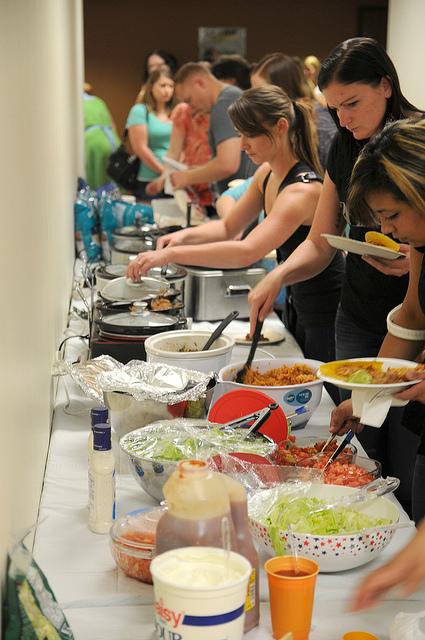What are the utensils that are black?
Write a very short answer. Spoons. What kind of cup is the red cup?
Give a very brief answer. Plastic cup. How many kids are in the scene?
Keep it brief. 0. Are they drinking soda?
Quick response, please. No. Is this a buffet style dinner?
Keep it brief. Yes. Is there a man in this picture?
Be succinct. Yes. What are they eating?
Concise answer only. Salad. What condiment is on the table?
Concise answer only. Sour cream. Is there sour cream in the photo?
Write a very short answer. Yes. What condiment is shown?
Short answer required. Salad dressing. Is the plastic container with the spoon in it full?
Keep it brief. Yes. What material is the wall on the left made out of?
Give a very brief answer. Plaster. What organization are these members of?
Keep it brief. Pta. Which wrist is the watch on?
Be succinct. Left. What size is the food?
Short answer required. Large. 